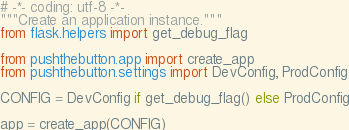Convert code to text. <code><loc_0><loc_0><loc_500><loc_500><_Python_># -*- coding: utf-8 -*-
"""Create an application instance."""
from flask.helpers import get_debug_flag

from pushthebutton.app import create_app
from pushthebutton.settings import DevConfig, ProdConfig

CONFIG = DevConfig if get_debug_flag() else ProdConfig

app = create_app(CONFIG)
</code> 